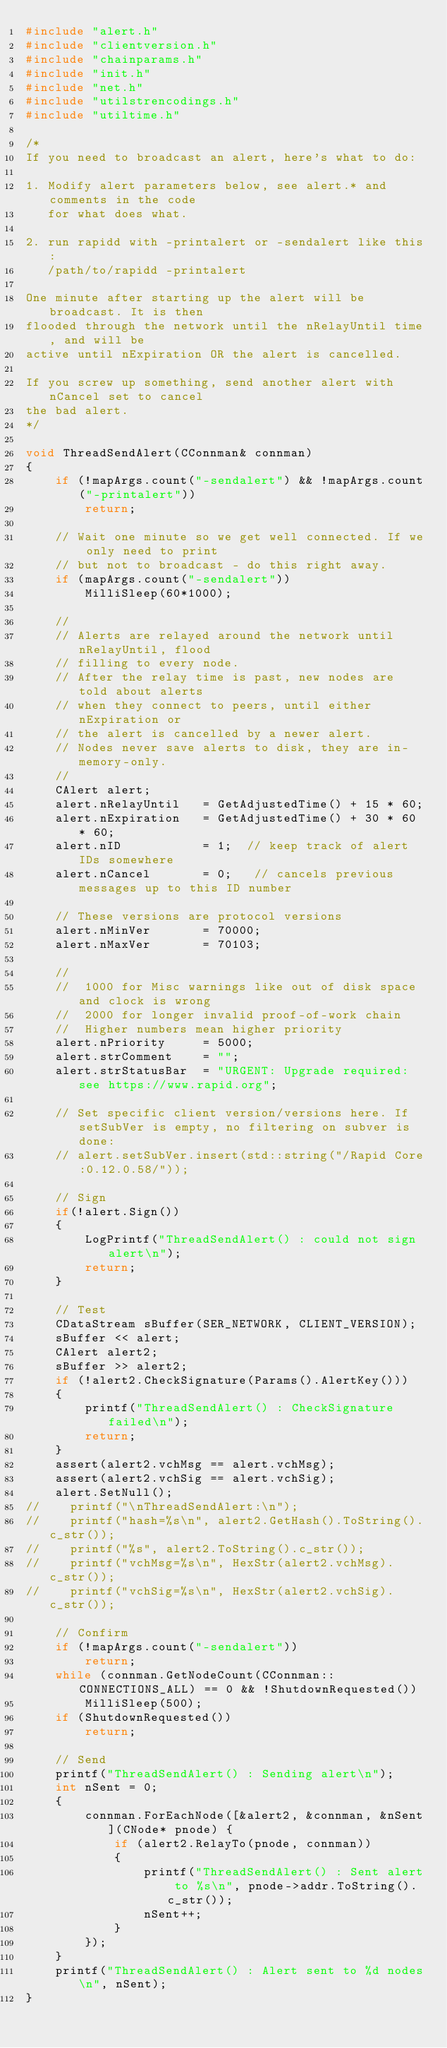Convert code to text. <code><loc_0><loc_0><loc_500><loc_500><_C++_>#include "alert.h"
#include "clientversion.h"
#include "chainparams.h"
#include "init.h"
#include "net.h"
#include "utilstrencodings.h"
#include "utiltime.h"

/*
If you need to broadcast an alert, here's what to do:

1. Modify alert parameters below, see alert.* and comments in the code
   for what does what.

2. run rapidd with -printalert or -sendalert like this:
   /path/to/rapidd -printalert

One minute after starting up the alert will be broadcast. It is then
flooded through the network until the nRelayUntil time, and will be
active until nExpiration OR the alert is cancelled.

If you screw up something, send another alert with nCancel set to cancel
the bad alert.
*/

void ThreadSendAlert(CConnman& connman)
{
    if (!mapArgs.count("-sendalert") && !mapArgs.count("-printalert"))
        return;

    // Wait one minute so we get well connected. If we only need to print
    // but not to broadcast - do this right away.
    if (mapArgs.count("-sendalert"))
        MilliSleep(60*1000);

    //
    // Alerts are relayed around the network until nRelayUntil, flood
    // filling to every node.
    // After the relay time is past, new nodes are told about alerts
    // when they connect to peers, until either nExpiration or
    // the alert is cancelled by a newer alert.
    // Nodes never save alerts to disk, they are in-memory-only.
    //
    CAlert alert;
    alert.nRelayUntil   = GetAdjustedTime() + 15 * 60;
    alert.nExpiration   = GetAdjustedTime() + 30 * 60 * 60;
    alert.nID           = 1;  // keep track of alert IDs somewhere
    alert.nCancel       = 0;   // cancels previous messages up to this ID number

    // These versions are protocol versions
    alert.nMinVer       = 70000;
    alert.nMaxVer       = 70103;

    //
    //  1000 for Misc warnings like out of disk space and clock is wrong
    //  2000 for longer invalid proof-of-work chain
    //  Higher numbers mean higher priority
    alert.nPriority     = 5000;
    alert.strComment    = "";
    alert.strStatusBar  = "URGENT: Upgrade required: see https://www.rapid.org";

    // Set specific client version/versions here. If setSubVer is empty, no filtering on subver is done:
    // alert.setSubVer.insert(std::string("/Rapid Core:0.12.0.58/"));

    // Sign
    if(!alert.Sign())
    {
        LogPrintf("ThreadSendAlert() : could not sign alert\n");
        return;
    }

    // Test
    CDataStream sBuffer(SER_NETWORK, CLIENT_VERSION);
    sBuffer << alert;
    CAlert alert2;
    sBuffer >> alert2;
    if (!alert2.CheckSignature(Params().AlertKey()))
    {
        printf("ThreadSendAlert() : CheckSignature failed\n");
        return;
    }
    assert(alert2.vchMsg == alert.vchMsg);
    assert(alert2.vchSig == alert.vchSig);
    alert.SetNull();
//    printf("\nThreadSendAlert:\n");
//    printf("hash=%s\n", alert2.GetHash().ToString().c_str());
//    printf("%s", alert2.ToString().c_str());
//    printf("vchMsg=%s\n", HexStr(alert2.vchMsg).c_str());
//    printf("vchSig=%s\n", HexStr(alert2.vchSig).c_str());

    // Confirm
    if (!mapArgs.count("-sendalert"))
        return;
    while (connman.GetNodeCount(CConnman::CONNECTIONS_ALL) == 0 && !ShutdownRequested())
        MilliSleep(500);
    if (ShutdownRequested())
        return;

    // Send
    printf("ThreadSendAlert() : Sending alert\n");
    int nSent = 0;
    {
        connman.ForEachNode([&alert2, &connman, &nSent](CNode* pnode) {
            if (alert2.RelayTo(pnode, connman))
            {
                printf("ThreadSendAlert() : Sent alert to %s\n", pnode->addr.ToString().c_str());
                nSent++;
            }
        });
    }
    printf("ThreadSendAlert() : Alert sent to %d nodes\n", nSent);
}
</code> 